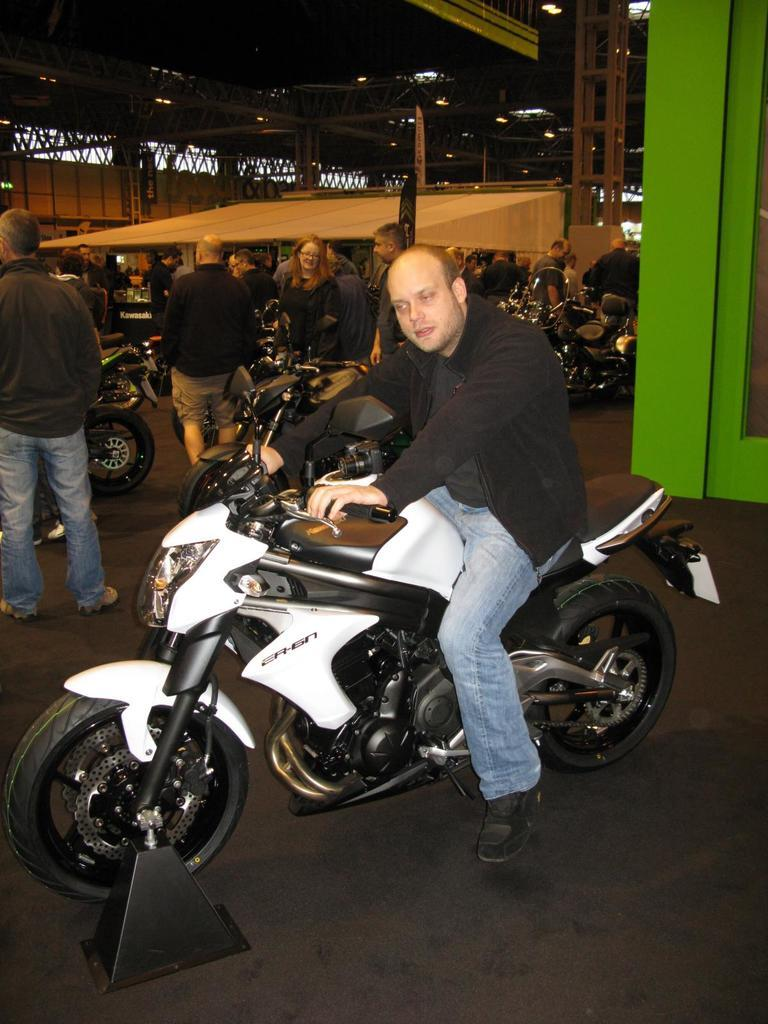What is the person in the image doing? The person is sitting on a motorbike. What are the other people in the image doing? There are groups of people standing. How many motorbikes are visible in the image? There are motorbikes in the image. What is the structure of the shelter in the image? The shelter is built with iron pillars. What type of face paint is the fireman wearing in the image? There is no fireman or face paint present in the image. 